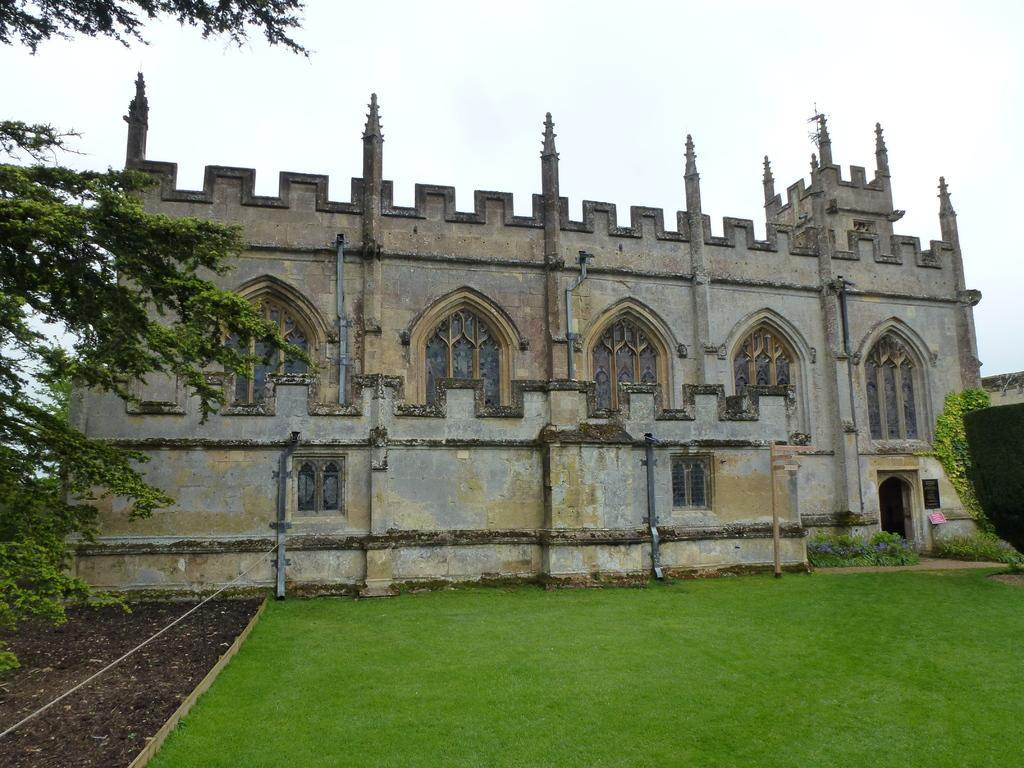What type of structure is visible in the image? There is a building in the image. What is on the ground in the image? There is grass on the ground in the image. What type of vegetation can be seen in the image? There are trees and plants in the image. What is visible in the sky in the image? The sky is cloudy in the image. What type of blade is being used to cut the steel in the image? There is no blade or steel present in the image; it features a building, grass, trees, plants, and a cloudy sky. 